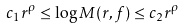<formula> <loc_0><loc_0><loc_500><loc_500>c _ { 1 } r ^ { \rho } \leq \log M ( r , f ) \leq c _ { 2 } r ^ { \rho }</formula> 